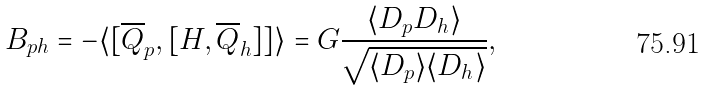<formula> <loc_0><loc_0><loc_500><loc_500>B _ { p h } = - \langle [ \overline { Q } _ { p } , [ H , \overline { Q } _ { h } ] ] \rangle = G \frac { \langle D _ { p } D _ { h } \rangle } { \sqrt { \langle D _ { p } \rangle \langle D _ { h } \rangle } } ,</formula> 